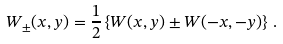Convert formula to latex. <formula><loc_0><loc_0><loc_500><loc_500>W _ { \pm } ( x , y ) = \frac { 1 } { 2 } \left \{ W ( x , y ) \pm W ( - x , - y ) \right \} \, .</formula> 